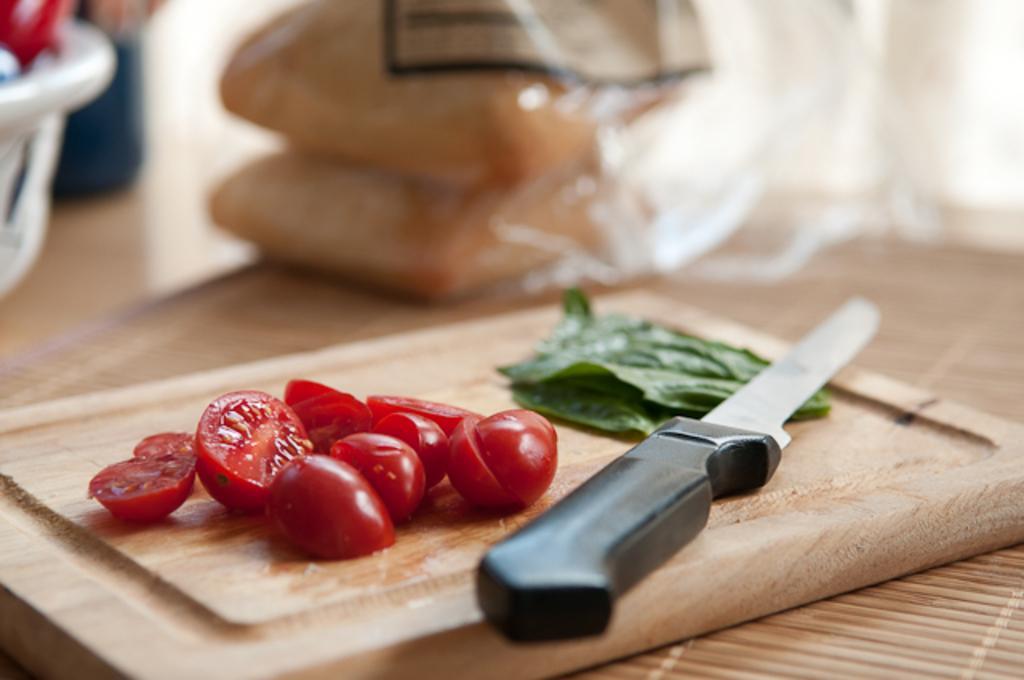In one or two sentences, can you explain what this image depicts? In this image in the front there are vegetables and there is a knife on the chopping board. In the background there are objects which are blurry. 